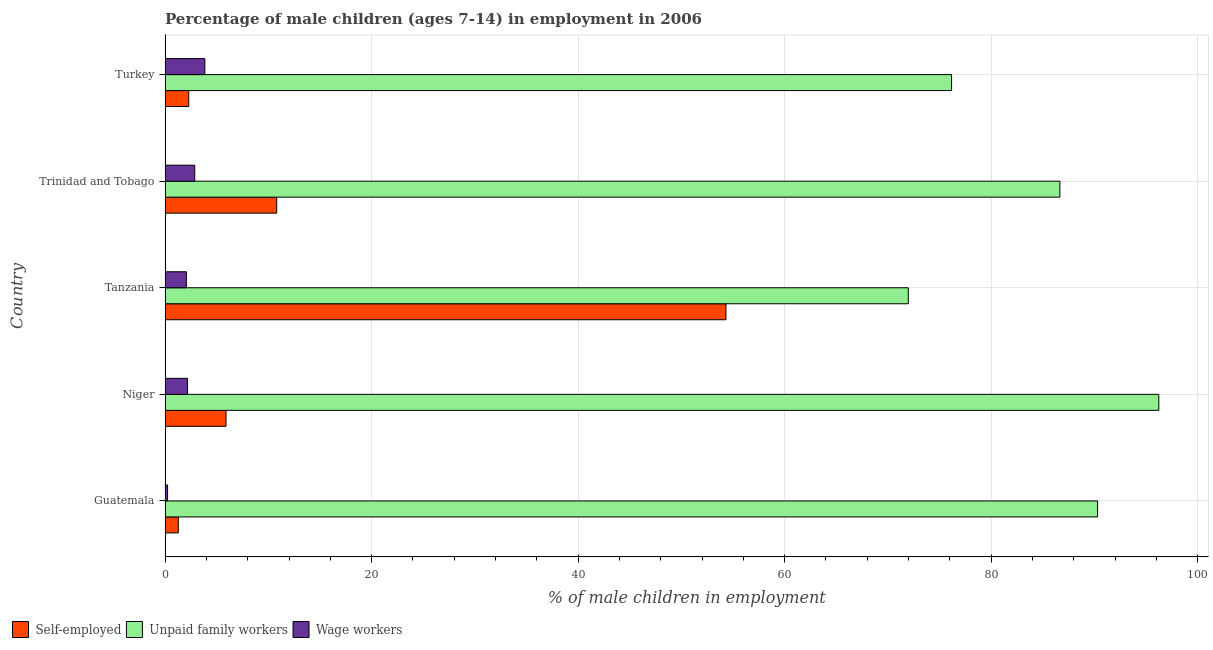How many different coloured bars are there?
Ensure brevity in your answer.  3. How many groups of bars are there?
Offer a terse response. 5. How many bars are there on the 2nd tick from the top?
Your answer should be very brief. 3. What is the percentage of children employed as wage workers in Turkey?
Make the answer very short. 3.85. Across all countries, what is the maximum percentage of children employed as unpaid family workers?
Offer a very short reply. 96.24. Across all countries, what is the minimum percentage of children employed as wage workers?
Offer a terse response. 0.24. In which country was the percentage of self employed children maximum?
Offer a terse response. Tanzania. In which country was the percentage of self employed children minimum?
Offer a terse response. Guatemala. What is the total percentage of children employed as wage workers in the graph?
Your response must be concise. 11.19. What is the difference between the percentage of children employed as unpaid family workers in Niger and that in Trinidad and Tobago?
Provide a short and direct response. 9.58. What is the difference between the percentage of children employed as wage workers in Turkey and the percentage of self employed children in Niger?
Provide a short and direct response. -2.05. What is the average percentage of children employed as unpaid family workers per country?
Offer a very short reply. 84.27. What is the difference between the percentage of self employed children and percentage of children employed as unpaid family workers in Guatemala?
Provide a succinct answer. -89.03. In how many countries, is the percentage of children employed as unpaid family workers greater than 56 %?
Ensure brevity in your answer.  5. What is the ratio of the percentage of children employed as unpaid family workers in Guatemala to that in Tanzania?
Give a very brief answer. 1.25. Is the difference between the percentage of self employed children in Tanzania and Turkey greater than the difference between the percentage of children employed as wage workers in Tanzania and Turkey?
Give a very brief answer. Yes. What is the difference between the highest and the second highest percentage of children employed as unpaid family workers?
Your answer should be very brief. 5.93. What is the difference between the highest and the lowest percentage of children employed as unpaid family workers?
Your answer should be compact. 24.26. In how many countries, is the percentage of children employed as unpaid family workers greater than the average percentage of children employed as unpaid family workers taken over all countries?
Your response must be concise. 3. What does the 2nd bar from the top in Tanzania represents?
Give a very brief answer. Unpaid family workers. What does the 2nd bar from the bottom in Tanzania represents?
Offer a terse response. Unpaid family workers. Is it the case that in every country, the sum of the percentage of self employed children and percentage of children employed as unpaid family workers is greater than the percentage of children employed as wage workers?
Offer a terse response. Yes. How many bars are there?
Offer a very short reply. 15. Are all the bars in the graph horizontal?
Your answer should be compact. Yes. Are the values on the major ticks of X-axis written in scientific E-notation?
Your answer should be compact. No. How are the legend labels stacked?
Give a very brief answer. Horizontal. What is the title of the graph?
Your answer should be very brief. Percentage of male children (ages 7-14) in employment in 2006. What is the label or title of the X-axis?
Make the answer very short. % of male children in employment. What is the label or title of the Y-axis?
Your response must be concise. Country. What is the % of male children in employment of Self-employed in Guatemala?
Your answer should be compact. 1.28. What is the % of male children in employment in Unpaid family workers in Guatemala?
Make the answer very short. 90.31. What is the % of male children in employment in Wage workers in Guatemala?
Offer a terse response. 0.24. What is the % of male children in employment in Self-employed in Niger?
Your answer should be very brief. 5.9. What is the % of male children in employment of Unpaid family workers in Niger?
Keep it short and to the point. 96.24. What is the % of male children in employment in Wage workers in Niger?
Keep it short and to the point. 2.17. What is the % of male children in employment of Self-employed in Tanzania?
Your answer should be compact. 54.32. What is the % of male children in employment in Unpaid family workers in Tanzania?
Offer a terse response. 71.98. What is the % of male children in employment in Wage workers in Tanzania?
Ensure brevity in your answer.  2.06. What is the % of male children in employment in Self-employed in Trinidad and Tobago?
Keep it short and to the point. 10.81. What is the % of male children in employment in Unpaid family workers in Trinidad and Tobago?
Your answer should be compact. 86.66. What is the % of male children in employment in Wage workers in Trinidad and Tobago?
Provide a short and direct response. 2.87. What is the % of male children in employment of Self-employed in Turkey?
Give a very brief answer. 2.29. What is the % of male children in employment of Unpaid family workers in Turkey?
Your answer should be compact. 76.17. What is the % of male children in employment of Wage workers in Turkey?
Give a very brief answer. 3.85. Across all countries, what is the maximum % of male children in employment of Self-employed?
Offer a terse response. 54.32. Across all countries, what is the maximum % of male children in employment in Unpaid family workers?
Provide a short and direct response. 96.24. Across all countries, what is the maximum % of male children in employment in Wage workers?
Your response must be concise. 3.85. Across all countries, what is the minimum % of male children in employment in Self-employed?
Offer a very short reply. 1.28. Across all countries, what is the minimum % of male children in employment of Unpaid family workers?
Offer a very short reply. 71.98. Across all countries, what is the minimum % of male children in employment of Wage workers?
Your response must be concise. 0.24. What is the total % of male children in employment in Self-employed in the graph?
Your answer should be compact. 74.6. What is the total % of male children in employment in Unpaid family workers in the graph?
Your response must be concise. 421.36. What is the total % of male children in employment in Wage workers in the graph?
Ensure brevity in your answer.  11.19. What is the difference between the % of male children in employment in Self-employed in Guatemala and that in Niger?
Your answer should be compact. -4.62. What is the difference between the % of male children in employment in Unpaid family workers in Guatemala and that in Niger?
Your answer should be very brief. -5.93. What is the difference between the % of male children in employment of Wage workers in Guatemala and that in Niger?
Keep it short and to the point. -1.93. What is the difference between the % of male children in employment in Self-employed in Guatemala and that in Tanzania?
Ensure brevity in your answer.  -53.04. What is the difference between the % of male children in employment of Unpaid family workers in Guatemala and that in Tanzania?
Offer a very short reply. 18.33. What is the difference between the % of male children in employment in Wage workers in Guatemala and that in Tanzania?
Your answer should be compact. -1.82. What is the difference between the % of male children in employment of Self-employed in Guatemala and that in Trinidad and Tobago?
Give a very brief answer. -9.53. What is the difference between the % of male children in employment in Unpaid family workers in Guatemala and that in Trinidad and Tobago?
Provide a succinct answer. 3.65. What is the difference between the % of male children in employment of Wage workers in Guatemala and that in Trinidad and Tobago?
Make the answer very short. -2.63. What is the difference between the % of male children in employment in Self-employed in Guatemala and that in Turkey?
Give a very brief answer. -1.01. What is the difference between the % of male children in employment of Unpaid family workers in Guatemala and that in Turkey?
Make the answer very short. 14.14. What is the difference between the % of male children in employment of Wage workers in Guatemala and that in Turkey?
Offer a very short reply. -3.61. What is the difference between the % of male children in employment in Self-employed in Niger and that in Tanzania?
Give a very brief answer. -48.42. What is the difference between the % of male children in employment in Unpaid family workers in Niger and that in Tanzania?
Your answer should be compact. 24.26. What is the difference between the % of male children in employment in Wage workers in Niger and that in Tanzania?
Keep it short and to the point. 0.11. What is the difference between the % of male children in employment of Self-employed in Niger and that in Trinidad and Tobago?
Provide a succinct answer. -4.91. What is the difference between the % of male children in employment of Unpaid family workers in Niger and that in Trinidad and Tobago?
Ensure brevity in your answer.  9.58. What is the difference between the % of male children in employment in Wage workers in Niger and that in Trinidad and Tobago?
Keep it short and to the point. -0.7. What is the difference between the % of male children in employment of Self-employed in Niger and that in Turkey?
Offer a terse response. 3.61. What is the difference between the % of male children in employment of Unpaid family workers in Niger and that in Turkey?
Your answer should be very brief. 20.07. What is the difference between the % of male children in employment in Wage workers in Niger and that in Turkey?
Your answer should be compact. -1.68. What is the difference between the % of male children in employment of Self-employed in Tanzania and that in Trinidad and Tobago?
Keep it short and to the point. 43.51. What is the difference between the % of male children in employment in Unpaid family workers in Tanzania and that in Trinidad and Tobago?
Your answer should be very brief. -14.68. What is the difference between the % of male children in employment of Wage workers in Tanzania and that in Trinidad and Tobago?
Your answer should be compact. -0.81. What is the difference between the % of male children in employment in Self-employed in Tanzania and that in Turkey?
Offer a very short reply. 52.03. What is the difference between the % of male children in employment of Unpaid family workers in Tanzania and that in Turkey?
Ensure brevity in your answer.  -4.19. What is the difference between the % of male children in employment in Wage workers in Tanzania and that in Turkey?
Give a very brief answer. -1.79. What is the difference between the % of male children in employment of Self-employed in Trinidad and Tobago and that in Turkey?
Ensure brevity in your answer.  8.52. What is the difference between the % of male children in employment in Unpaid family workers in Trinidad and Tobago and that in Turkey?
Offer a terse response. 10.49. What is the difference between the % of male children in employment of Wage workers in Trinidad and Tobago and that in Turkey?
Keep it short and to the point. -0.98. What is the difference between the % of male children in employment of Self-employed in Guatemala and the % of male children in employment of Unpaid family workers in Niger?
Ensure brevity in your answer.  -94.96. What is the difference between the % of male children in employment of Self-employed in Guatemala and the % of male children in employment of Wage workers in Niger?
Your response must be concise. -0.89. What is the difference between the % of male children in employment in Unpaid family workers in Guatemala and the % of male children in employment in Wage workers in Niger?
Give a very brief answer. 88.14. What is the difference between the % of male children in employment in Self-employed in Guatemala and the % of male children in employment in Unpaid family workers in Tanzania?
Keep it short and to the point. -70.7. What is the difference between the % of male children in employment of Self-employed in Guatemala and the % of male children in employment of Wage workers in Tanzania?
Keep it short and to the point. -0.78. What is the difference between the % of male children in employment of Unpaid family workers in Guatemala and the % of male children in employment of Wage workers in Tanzania?
Offer a terse response. 88.25. What is the difference between the % of male children in employment in Self-employed in Guatemala and the % of male children in employment in Unpaid family workers in Trinidad and Tobago?
Your answer should be very brief. -85.38. What is the difference between the % of male children in employment in Self-employed in Guatemala and the % of male children in employment in Wage workers in Trinidad and Tobago?
Provide a succinct answer. -1.59. What is the difference between the % of male children in employment of Unpaid family workers in Guatemala and the % of male children in employment of Wage workers in Trinidad and Tobago?
Offer a terse response. 87.44. What is the difference between the % of male children in employment in Self-employed in Guatemala and the % of male children in employment in Unpaid family workers in Turkey?
Keep it short and to the point. -74.89. What is the difference between the % of male children in employment in Self-employed in Guatemala and the % of male children in employment in Wage workers in Turkey?
Provide a short and direct response. -2.57. What is the difference between the % of male children in employment in Unpaid family workers in Guatemala and the % of male children in employment in Wage workers in Turkey?
Your answer should be compact. 86.46. What is the difference between the % of male children in employment of Self-employed in Niger and the % of male children in employment of Unpaid family workers in Tanzania?
Provide a short and direct response. -66.08. What is the difference between the % of male children in employment of Self-employed in Niger and the % of male children in employment of Wage workers in Tanzania?
Your answer should be compact. 3.84. What is the difference between the % of male children in employment of Unpaid family workers in Niger and the % of male children in employment of Wage workers in Tanzania?
Provide a short and direct response. 94.18. What is the difference between the % of male children in employment in Self-employed in Niger and the % of male children in employment in Unpaid family workers in Trinidad and Tobago?
Give a very brief answer. -80.76. What is the difference between the % of male children in employment of Self-employed in Niger and the % of male children in employment of Wage workers in Trinidad and Tobago?
Ensure brevity in your answer.  3.03. What is the difference between the % of male children in employment in Unpaid family workers in Niger and the % of male children in employment in Wage workers in Trinidad and Tobago?
Your answer should be very brief. 93.37. What is the difference between the % of male children in employment in Self-employed in Niger and the % of male children in employment in Unpaid family workers in Turkey?
Give a very brief answer. -70.27. What is the difference between the % of male children in employment of Self-employed in Niger and the % of male children in employment of Wage workers in Turkey?
Offer a very short reply. 2.05. What is the difference between the % of male children in employment of Unpaid family workers in Niger and the % of male children in employment of Wage workers in Turkey?
Your response must be concise. 92.39. What is the difference between the % of male children in employment of Self-employed in Tanzania and the % of male children in employment of Unpaid family workers in Trinidad and Tobago?
Your answer should be very brief. -32.34. What is the difference between the % of male children in employment in Self-employed in Tanzania and the % of male children in employment in Wage workers in Trinidad and Tobago?
Offer a terse response. 51.45. What is the difference between the % of male children in employment in Unpaid family workers in Tanzania and the % of male children in employment in Wage workers in Trinidad and Tobago?
Offer a terse response. 69.11. What is the difference between the % of male children in employment in Self-employed in Tanzania and the % of male children in employment in Unpaid family workers in Turkey?
Make the answer very short. -21.85. What is the difference between the % of male children in employment in Self-employed in Tanzania and the % of male children in employment in Wage workers in Turkey?
Provide a succinct answer. 50.47. What is the difference between the % of male children in employment of Unpaid family workers in Tanzania and the % of male children in employment of Wage workers in Turkey?
Keep it short and to the point. 68.13. What is the difference between the % of male children in employment in Self-employed in Trinidad and Tobago and the % of male children in employment in Unpaid family workers in Turkey?
Provide a succinct answer. -65.36. What is the difference between the % of male children in employment of Self-employed in Trinidad and Tobago and the % of male children in employment of Wage workers in Turkey?
Give a very brief answer. 6.96. What is the difference between the % of male children in employment of Unpaid family workers in Trinidad and Tobago and the % of male children in employment of Wage workers in Turkey?
Keep it short and to the point. 82.81. What is the average % of male children in employment in Self-employed per country?
Ensure brevity in your answer.  14.92. What is the average % of male children in employment in Unpaid family workers per country?
Ensure brevity in your answer.  84.27. What is the average % of male children in employment in Wage workers per country?
Ensure brevity in your answer.  2.24. What is the difference between the % of male children in employment of Self-employed and % of male children in employment of Unpaid family workers in Guatemala?
Your answer should be very brief. -89.03. What is the difference between the % of male children in employment of Unpaid family workers and % of male children in employment of Wage workers in Guatemala?
Provide a short and direct response. 90.07. What is the difference between the % of male children in employment of Self-employed and % of male children in employment of Unpaid family workers in Niger?
Your response must be concise. -90.34. What is the difference between the % of male children in employment in Self-employed and % of male children in employment in Wage workers in Niger?
Provide a succinct answer. 3.73. What is the difference between the % of male children in employment of Unpaid family workers and % of male children in employment of Wage workers in Niger?
Give a very brief answer. 94.07. What is the difference between the % of male children in employment in Self-employed and % of male children in employment in Unpaid family workers in Tanzania?
Offer a very short reply. -17.66. What is the difference between the % of male children in employment in Self-employed and % of male children in employment in Wage workers in Tanzania?
Offer a terse response. 52.26. What is the difference between the % of male children in employment in Unpaid family workers and % of male children in employment in Wage workers in Tanzania?
Your response must be concise. 69.92. What is the difference between the % of male children in employment of Self-employed and % of male children in employment of Unpaid family workers in Trinidad and Tobago?
Make the answer very short. -75.85. What is the difference between the % of male children in employment in Self-employed and % of male children in employment in Wage workers in Trinidad and Tobago?
Provide a short and direct response. 7.94. What is the difference between the % of male children in employment in Unpaid family workers and % of male children in employment in Wage workers in Trinidad and Tobago?
Provide a succinct answer. 83.79. What is the difference between the % of male children in employment in Self-employed and % of male children in employment in Unpaid family workers in Turkey?
Make the answer very short. -73.88. What is the difference between the % of male children in employment in Self-employed and % of male children in employment in Wage workers in Turkey?
Give a very brief answer. -1.56. What is the difference between the % of male children in employment in Unpaid family workers and % of male children in employment in Wage workers in Turkey?
Ensure brevity in your answer.  72.32. What is the ratio of the % of male children in employment of Self-employed in Guatemala to that in Niger?
Make the answer very short. 0.22. What is the ratio of the % of male children in employment in Unpaid family workers in Guatemala to that in Niger?
Make the answer very short. 0.94. What is the ratio of the % of male children in employment in Wage workers in Guatemala to that in Niger?
Ensure brevity in your answer.  0.11. What is the ratio of the % of male children in employment in Self-employed in Guatemala to that in Tanzania?
Your answer should be very brief. 0.02. What is the ratio of the % of male children in employment of Unpaid family workers in Guatemala to that in Tanzania?
Make the answer very short. 1.25. What is the ratio of the % of male children in employment of Wage workers in Guatemala to that in Tanzania?
Your answer should be very brief. 0.12. What is the ratio of the % of male children in employment of Self-employed in Guatemala to that in Trinidad and Tobago?
Provide a succinct answer. 0.12. What is the ratio of the % of male children in employment of Unpaid family workers in Guatemala to that in Trinidad and Tobago?
Your answer should be compact. 1.04. What is the ratio of the % of male children in employment of Wage workers in Guatemala to that in Trinidad and Tobago?
Provide a short and direct response. 0.08. What is the ratio of the % of male children in employment in Self-employed in Guatemala to that in Turkey?
Give a very brief answer. 0.56. What is the ratio of the % of male children in employment in Unpaid family workers in Guatemala to that in Turkey?
Offer a very short reply. 1.19. What is the ratio of the % of male children in employment in Wage workers in Guatemala to that in Turkey?
Your answer should be compact. 0.06. What is the ratio of the % of male children in employment in Self-employed in Niger to that in Tanzania?
Provide a succinct answer. 0.11. What is the ratio of the % of male children in employment of Unpaid family workers in Niger to that in Tanzania?
Offer a very short reply. 1.34. What is the ratio of the % of male children in employment of Wage workers in Niger to that in Tanzania?
Make the answer very short. 1.05. What is the ratio of the % of male children in employment of Self-employed in Niger to that in Trinidad and Tobago?
Offer a terse response. 0.55. What is the ratio of the % of male children in employment of Unpaid family workers in Niger to that in Trinidad and Tobago?
Your answer should be very brief. 1.11. What is the ratio of the % of male children in employment in Wage workers in Niger to that in Trinidad and Tobago?
Make the answer very short. 0.76. What is the ratio of the % of male children in employment in Self-employed in Niger to that in Turkey?
Offer a terse response. 2.58. What is the ratio of the % of male children in employment of Unpaid family workers in Niger to that in Turkey?
Your response must be concise. 1.26. What is the ratio of the % of male children in employment of Wage workers in Niger to that in Turkey?
Your response must be concise. 0.56. What is the ratio of the % of male children in employment of Self-employed in Tanzania to that in Trinidad and Tobago?
Your answer should be very brief. 5.03. What is the ratio of the % of male children in employment of Unpaid family workers in Tanzania to that in Trinidad and Tobago?
Give a very brief answer. 0.83. What is the ratio of the % of male children in employment of Wage workers in Tanzania to that in Trinidad and Tobago?
Offer a terse response. 0.72. What is the ratio of the % of male children in employment of Self-employed in Tanzania to that in Turkey?
Your answer should be compact. 23.72. What is the ratio of the % of male children in employment of Unpaid family workers in Tanzania to that in Turkey?
Your response must be concise. 0.94. What is the ratio of the % of male children in employment in Wage workers in Tanzania to that in Turkey?
Give a very brief answer. 0.54. What is the ratio of the % of male children in employment in Self-employed in Trinidad and Tobago to that in Turkey?
Ensure brevity in your answer.  4.72. What is the ratio of the % of male children in employment in Unpaid family workers in Trinidad and Tobago to that in Turkey?
Offer a very short reply. 1.14. What is the ratio of the % of male children in employment in Wage workers in Trinidad and Tobago to that in Turkey?
Your answer should be compact. 0.75. What is the difference between the highest and the second highest % of male children in employment of Self-employed?
Offer a very short reply. 43.51. What is the difference between the highest and the second highest % of male children in employment of Unpaid family workers?
Keep it short and to the point. 5.93. What is the difference between the highest and the lowest % of male children in employment of Self-employed?
Your answer should be very brief. 53.04. What is the difference between the highest and the lowest % of male children in employment in Unpaid family workers?
Give a very brief answer. 24.26. What is the difference between the highest and the lowest % of male children in employment in Wage workers?
Offer a terse response. 3.61. 